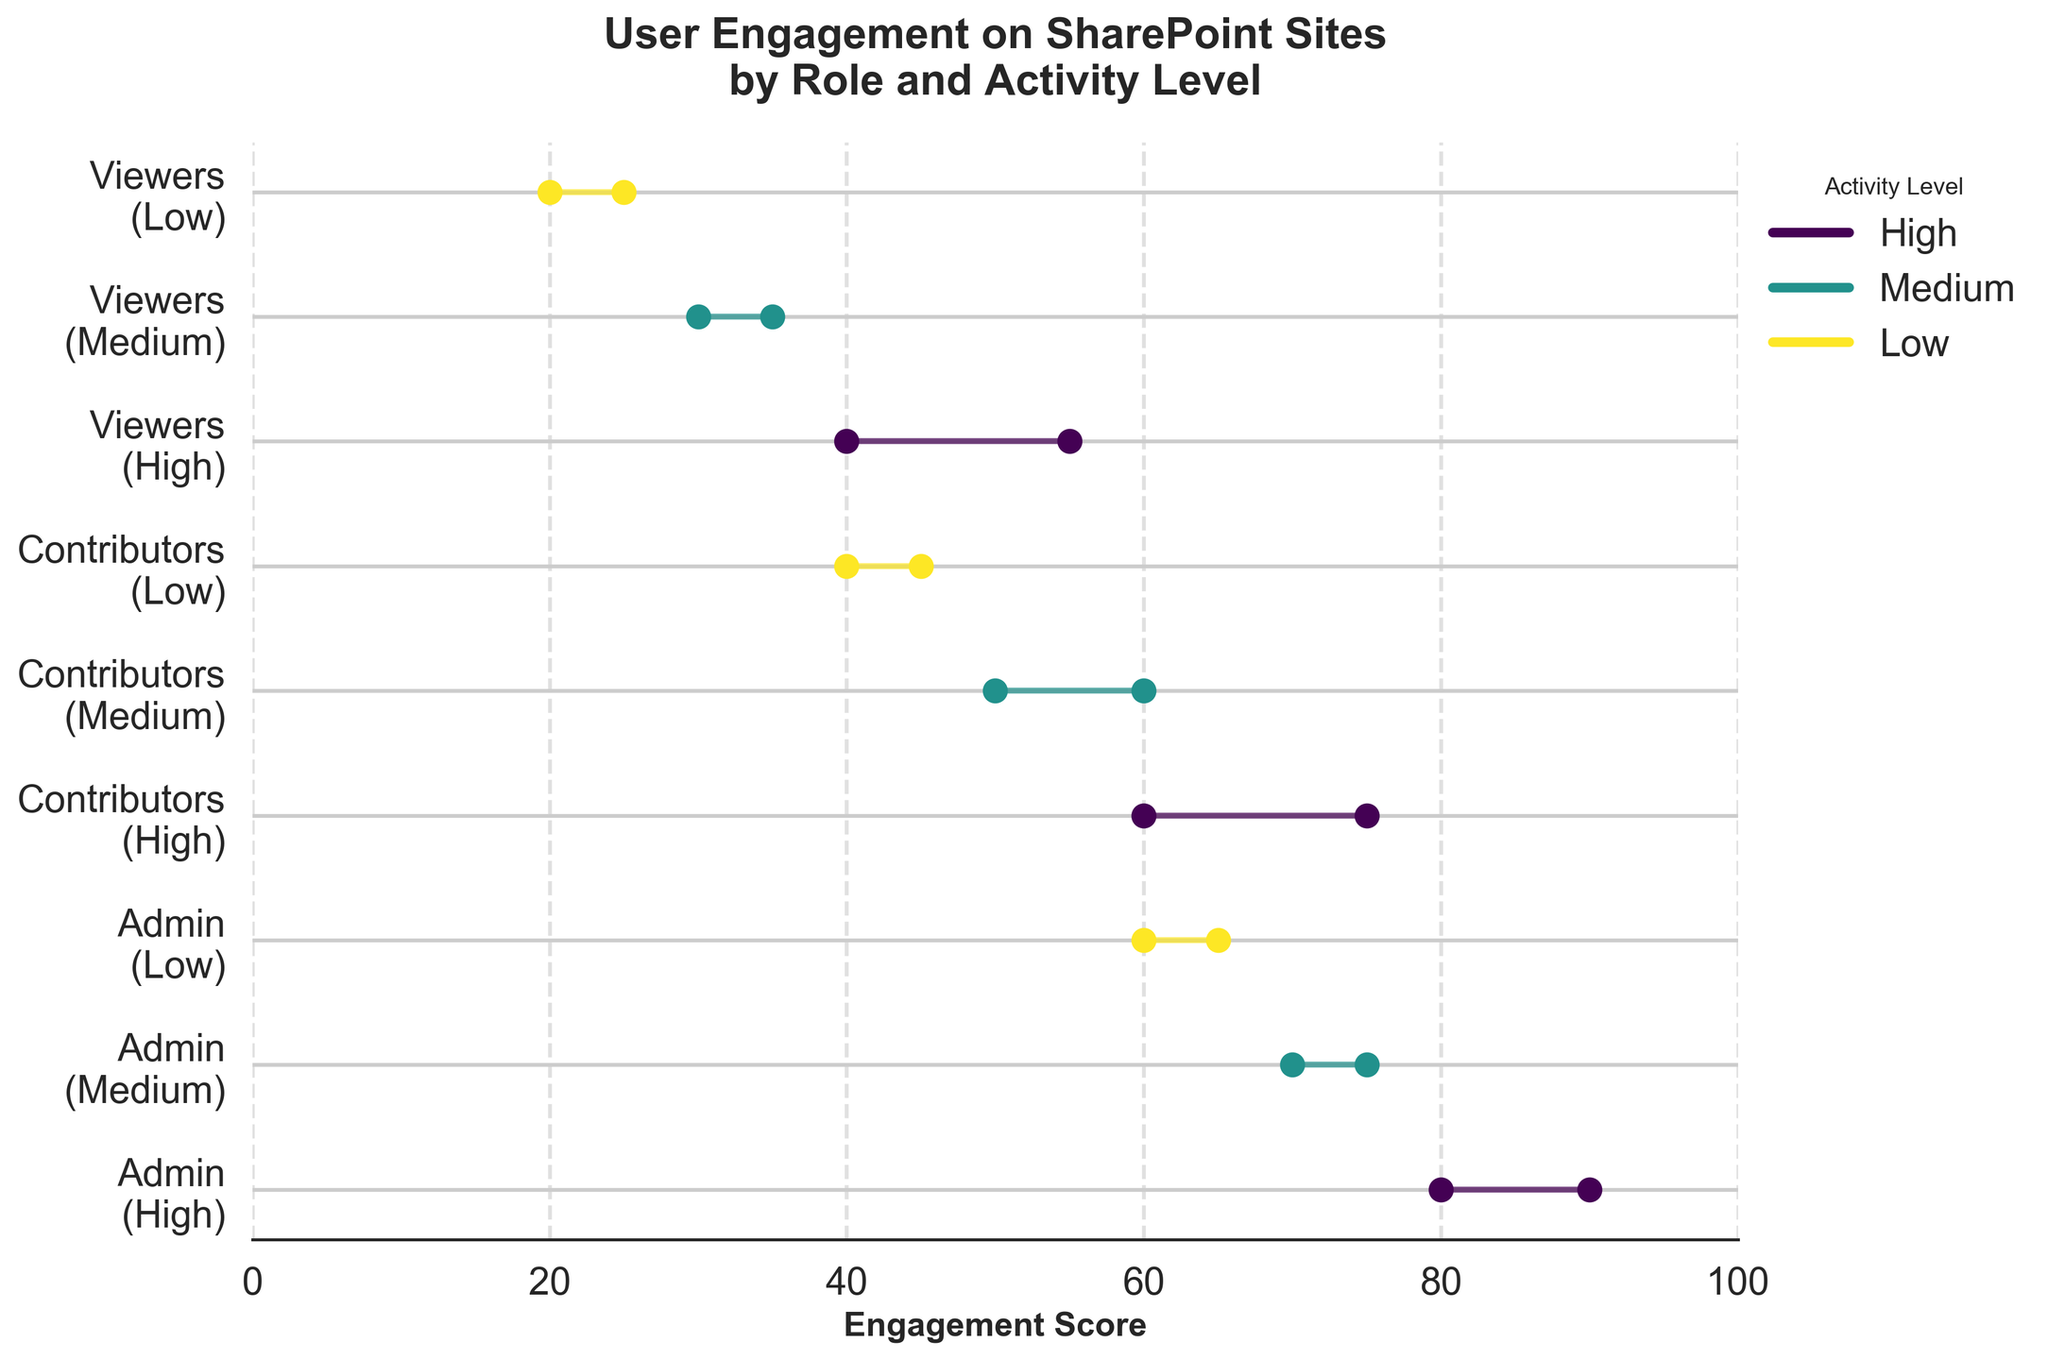How many roles are displayed in the plot? The y-axis shows labels combining the roles and activity levels. By counting unique role labels (without considering activity levels), we can see there are three distinct roles.
Answer: 3 What's the highest engagement score range for the Admin role? The Admin role's engagement ranges from 60 to 90. The highest segment, which is for Admins with High activity, ranges from 80 to 90.
Answer: 80-90 What is the difference in engagement scores for Contributors with High and Medium activity levels? For High activity Contributors, the engagement scores range from 60 to 75. For Medium activity Contributors, the range is 50 to 60. Calculating the difference between the end of High and start of Medium gives 75 - 50 = 25.
Answer: 25 Which role and activity level combination has the lowest start engagement score? By examining the left endpoints of the dumbbells, the combination with the lowest start is Viewers with Low activity, starting at 20.
Answer: Viewers with Low activity Are there any roles where the engagement start and end points are the same for all activity levels? Checking each role at all activity levels, none have fixed engagement start and ends. Therefore, no role-activity pairs have the same engagement scores across all levels.
Answer: No Which activity level has the most consistent engagement range from start to end across all roles? Consistency is checked by calculating the differences between start and end scores for each role and averaging them per activity level. With smaller differences representing more consistency, the Low activity level has ranges (5 for Admins, 5 for Contributors, 5 for Viewers), averaging consistent differences.
Answer: Low activity What is the engagement score range for Medium activity levels across all roles? Collecting and combining engagement scores for Medium activity for each role: Admin (70-75), Contributors (50-60), and Viewers (30-35). Therefore, the combined range is from 30 to 75.
Answer: 30-75 Do High activity levels generally have higher engagement scores compared to Low activity levels? By observing all High activity levels (80, 90, 60, 75, 40, 55) and all Low activity levels (60, 65, 40, 45, 20, 25), the scores in High activity levels are generally higher when comparing matched roles.
Answer: Yes Which group shows the largest improvement in engagement from start to end within their activity level? Improvement is marked by the range between start and end scores. The largest improvement is seen in Contributors with High activity levels, from 60 to 75, resulting in a 15-point increase.
Answer: Contributors with High activity What is the average End engagement score for Viewers across all activity levels? The End scores for Viewers are 55 (High), 35 (Medium), and 25 (Low). The average is calculated by summing these scores (55 + 35 + 25) and dividing by the number of activity levels, which is 3. Thus, (55 + 35 + 25) / 3 = 38.33.
Answer: 38.33 